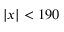Convert formula to latex. <formula><loc_0><loc_0><loc_500><loc_500>| x | < 1 9 0</formula> 